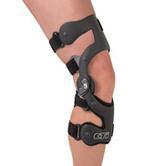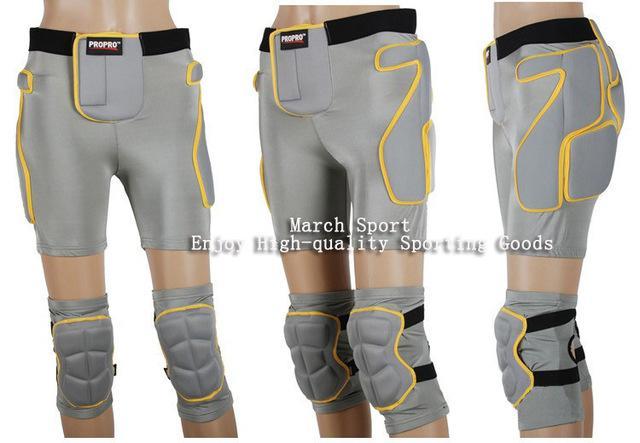The first image is the image on the left, the second image is the image on the right. For the images shown, is this caption "One of the knee braces has a small hole at the knee cap in an otherwise solid brace." true? Answer yes or no. No. The first image is the image on the left, the second image is the image on the right. For the images displayed, is the sentence "There is 1 or more joint wraps being displayed on a mannequin." factually correct? Answer yes or no. Yes. 